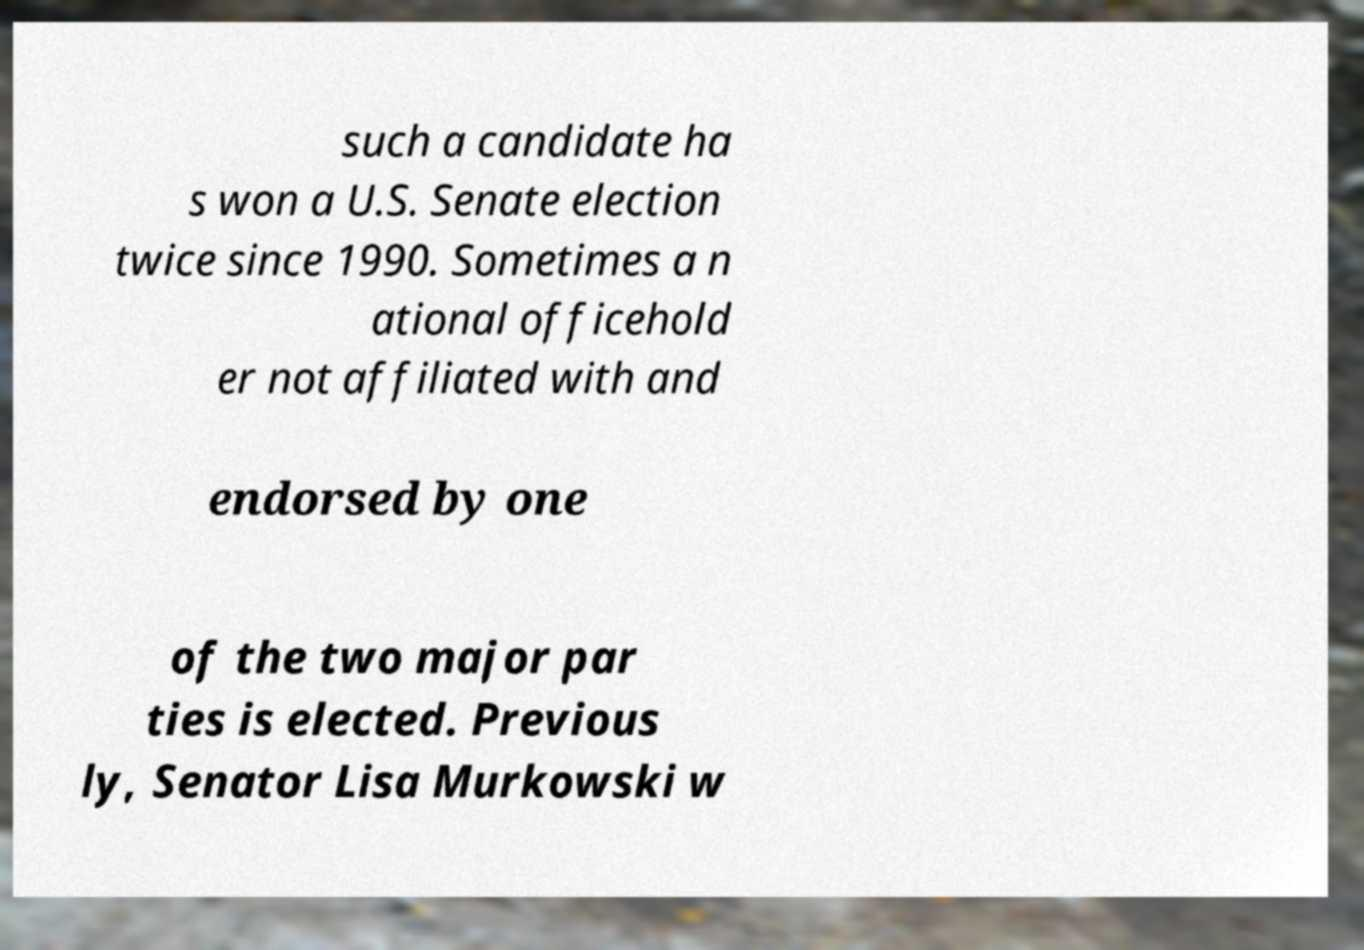There's text embedded in this image that I need extracted. Can you transcribe it verbatim? such a candidate ha s won a U.S. Senate election twice since 1990. Sometimes a n ational officehold er not affiliated with and endorsed by one of the two major par ties is elected. Previous ly, Senator Lisa Murkowski w 